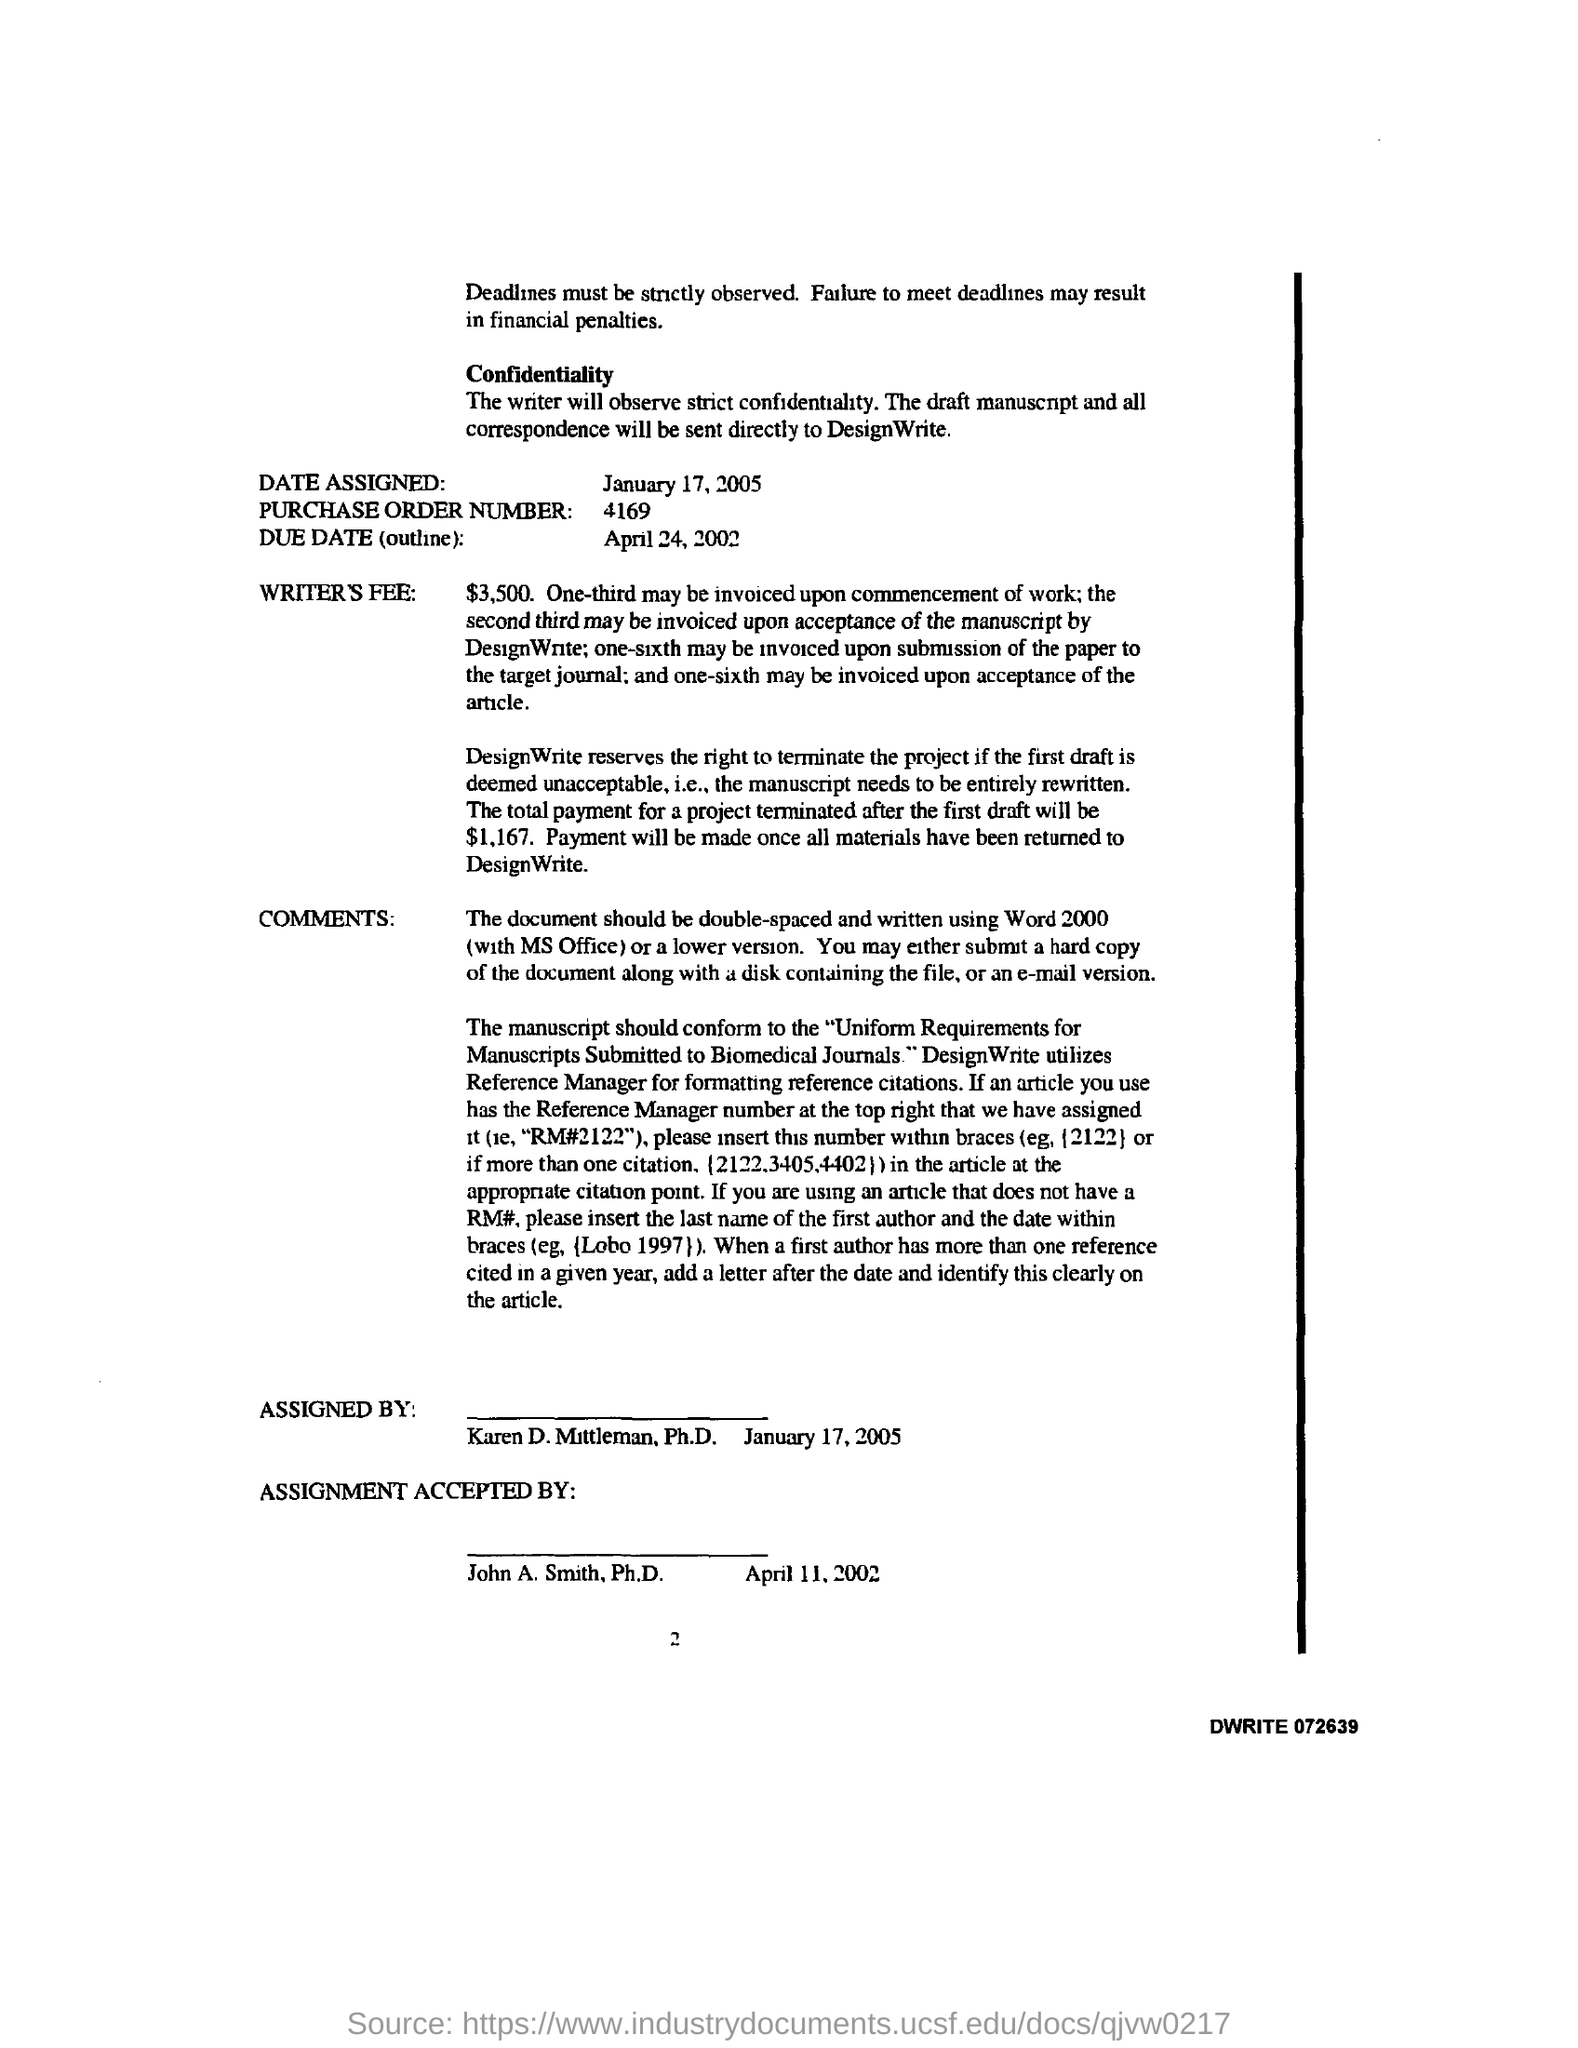Specify some key components in this picture. The purchase order number is 4169. The due date is April 24, 2002, as outlined. The design writer utilizes whom for formatting reference citations. Reference manager is the tool used for this purpose. The total payment for a project terminated after the first draft is $1,167. 